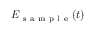Convert formula to latex. <formula><loc_0><loc_0><loc_500><loc_500>E _ { s a m p l e } ( t )</formula> 